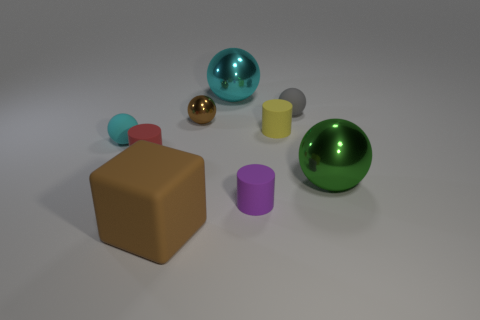Which object stands out the most and why? The green spherical object stands out prominently due to its vibrant color, which contrasts with the more muted tones of other items. Its reflective surface also draws the eye by capturing highlights and surrounding elements, providing visual interest within the scene. 